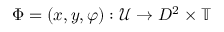Convert formula to latex. <formula><loc_0><loc_0><loc_500><loc_500>\Phi = ( x , y , \varphi ) \colon \mathcal { U } \rightarrow D ^ { 2 } \times \mathbb { T }</formula> 